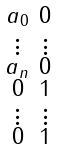<formula> <loc_0><loc_0><loc_500><loc_500>\begin{smallmatrix} a _ { 0 } & 0 \\ \vdots & \vdots \\ a _ { n } & 0 \\ 0 & 1 \\ \vdots & \vdots \\ 0 & 1 \end{smallmatrix}</formula> 